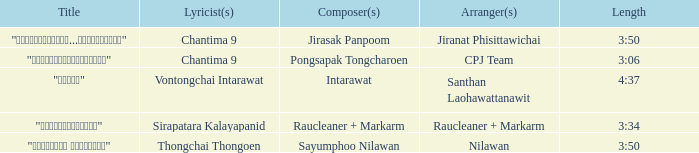Who was the arranger of "ขอโทษ"? Santhan Laohawattanawit. Would you be able to parse every entry in this table? {'header': ['Title', 'Lyricist(s)', 'Composer(s)', 'Arranger(s)', 'Length'], 'rows': [['"เรายังรักกัน...ไม่ใช่เหรอ"', 'Chantima 9', 'Jirasak Panpoom', 'Jiranat Phisittawichai', '3:50'], ['"นางฟ้าตาชั้นเดียว"', 'Chantima 9', 'Pongsapak Tongcharoen', 'CPJ Team', '3:06'], ['"ขอโทษ"', 'Vontongchai Intarawat', 'Intarawat', 'Santhan Laohawattanawit', '4:37'], ['"แค่อยากให้รู้"', 'Sirapatara Kalayapanid', 'Raucleaner + Markarm', 'Raucleaner + Markarm', '3:34'], ['"เลือกลืม เลือกจำ"', 'Thongchai Thongoen', 'Sayumphoo Nilawan', 'Nilawan', '3:50']]} 